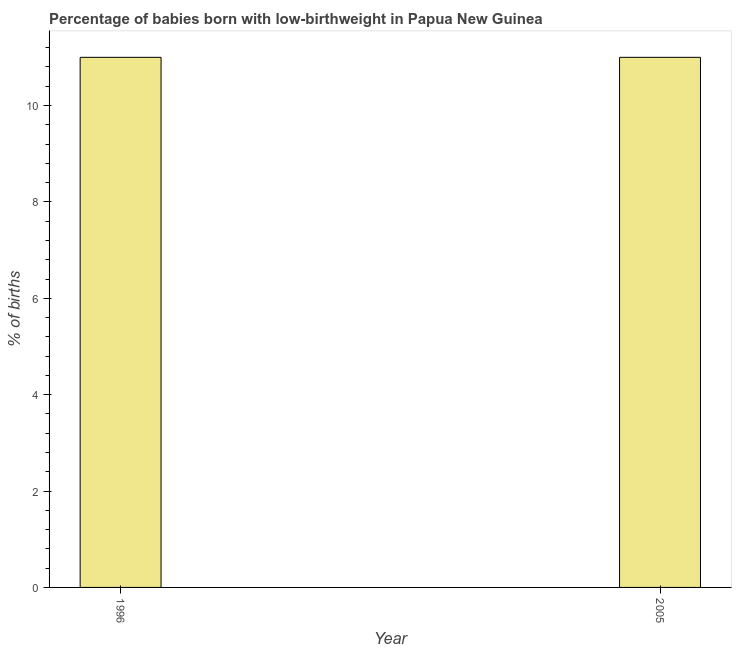Does the graph contain grids?
Make the answer very short. No. What is the title of the graph?
Ensure brevity in your answer.  Percentage of babies born with low-birthweight in Papua New Guinea. What is the label or title of the X-axis?
Offer a terse response. Year. What is the label or title of the Y-axis?
Your answer should be very brief. % of births. What is the percentage of babies who were born with low-birthweight in 1996?
Offer a terse response. 11. What is the sum of the percentage of babies who were born with low-birthweight?
Your response must be concise. 22. What is the median percentage of babies who were born with low-birthweight?
Make the answer very short. 11. Do a majority of the years between 1996 and 2005 (inclusive) have percentage of babies who were born with low-birthweight greater than 8.8 %?
Ensure brevity in your answer.  Yes. What is the ratio of the percentage of babies who were born with low-birthweight in 1996 to that in 2005?
Ensure brevity in your answer.  1. Is the percentage of babies who were born with low-birthweight in 1996 less than that in 2005?
Offer a terse response. No. In how many years, is the percentage of babies who were born with low-birthweight greater than the average percentage of babies who were born with low-birthweight taken over all years?
Give a very brief answer. 0. How many bars are there?
Ensure brevity in your answer.  2. Are all the bars in the graph horizontal?
Give a very brief answer. No. How many years are there in the graph?
Your answer should be very brief. 2. What is the % of births in 1996?
Offer a terse response. 11. What is the % of births of 2005?
Your answer should be compact. 11. What is the difference between the % of births in 1996 and 2005?
Your answer should be compact. 0. What is the ratio of the % of births in 1996 to that in 2005?
Provide a succinct answer. 1. 